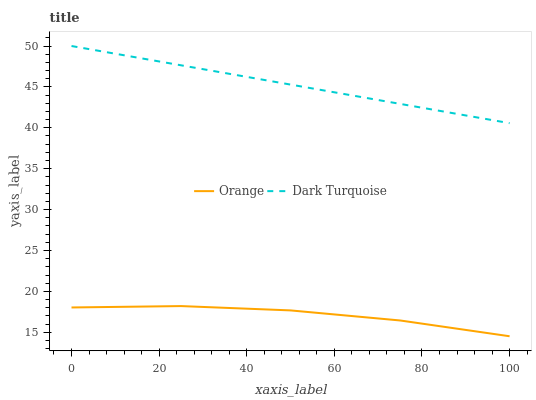Does Orange have the minimum area under the curve?
Answer yes or no. Yes. Does Dark Turquoise have the maximum area under the curve?
Answer yes or no. Yes. Does Dark Turquoise have the minimum area under the curve?
Answer yes or no. No. Is Dark Turquoise the smoothest?
Answer yes or no. Yes. Is Orange the roughest?
Answer yes or no. Yes. Is Dark Turquoise the roughest?
Answer yes or no. No. Does Orange have the lowest value?
Answer yes or no. Yes. Does Dark Turquoise have the lowest value?
Answer yes or no. No. Does Dark Turquoise have the highest value?
Answer yes or no. Yes. Is Orange less than Dark Turquoise?
Answer yes or no. Yes. Is Dark Turquoise greater than Orange?
Answer yes or no. Yes. Does Orange intersect Dark Turquoise?
Answer yes or no. No. 